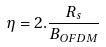<formula> <loc_0><loc_0><loc_500><loc_500>\eta = 2 . \frac { R _ { s } } { B _ { O F D M } }</formula> 